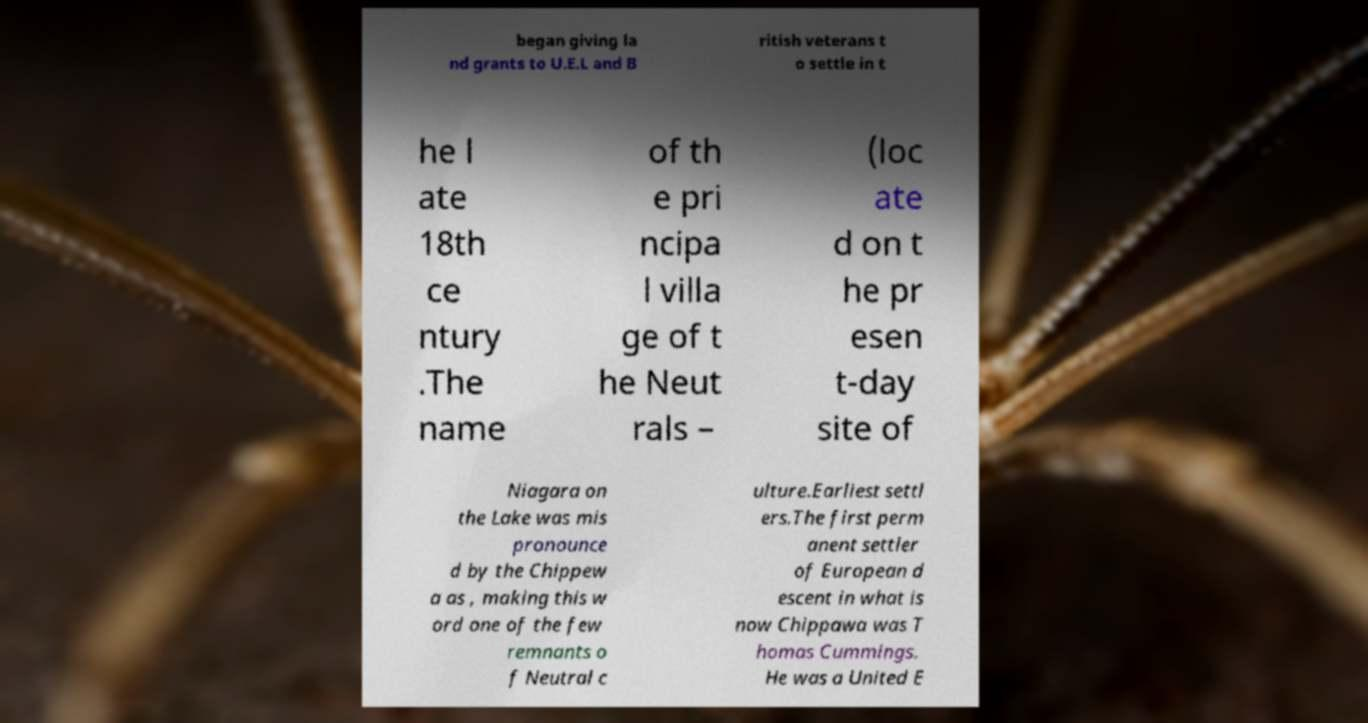There's text embedded in this image that I need extracted. Can you transcribe it verbatim? began giving la nd grants to U.E.L and B ritish veterans t o settle in t he l ate 18th ce ntury .The name of th e pri ncipa l villa ge of t he Neut rals – (loc ate d on t he pr esen t-day site of Niagara on the Lake was mis pronounce d by the Chippew a as , making this w ord one of the few remnants o f Neutral c ulture.Earliest settl ers.The first perm anent settler of European d escent in what is now Chippawa was T homas Cummings. He was a United E 